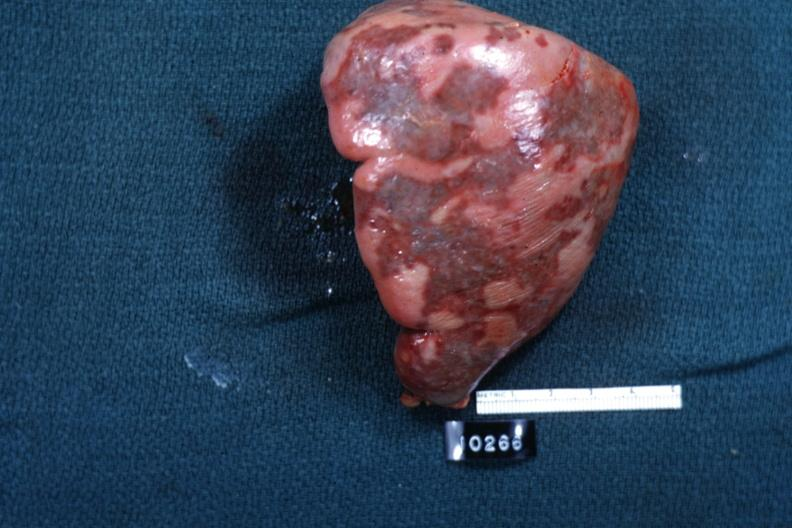s surface slide?
Answer the question using a single word or phrase. Yes 